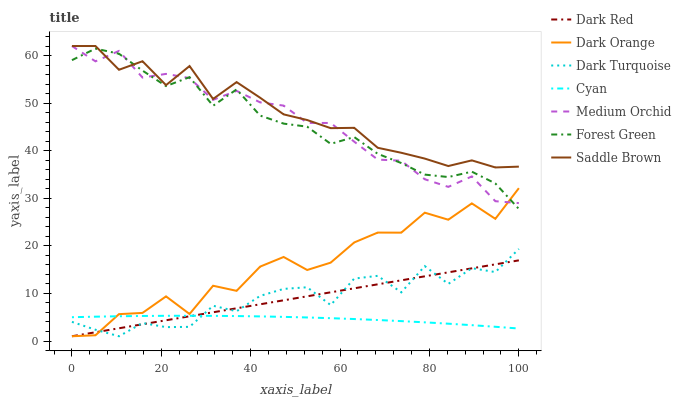Does Cyan have the minimum area under the curve?
Answer yes or no. Yes. Does Saddle Brown have the maximum area under the curve?
Answer yes or no. Yes. Does Dark Red have the minimum area under the curve?
Answer yes or no. No. Does Dark Red have the maximum area under the curve?
Answer yes or no. No. Is Dark Red the smoothest?
Answer yes or no. Yes. Is Dark Orange the roughest?
Answer yes or no. Yes. Is Medium Orchid the smoothest?
Answer yes or no. No. Is Medium Orchid the roughest?
Answer yes or no. No. Does Medium Orchid have the lowest value?
Answer yes or no. No. Does Dark Red have the highest value?
Answer yes or no. No. Is Dark Turquoise less than Medium Orchid?
Answer yes or no. Yes. Is Saddle Brown greater than Cyan?
Answer yes or no. Yes. Does Dark Turquoise intersect Medium Orchid?
Answer yes or no. No. 